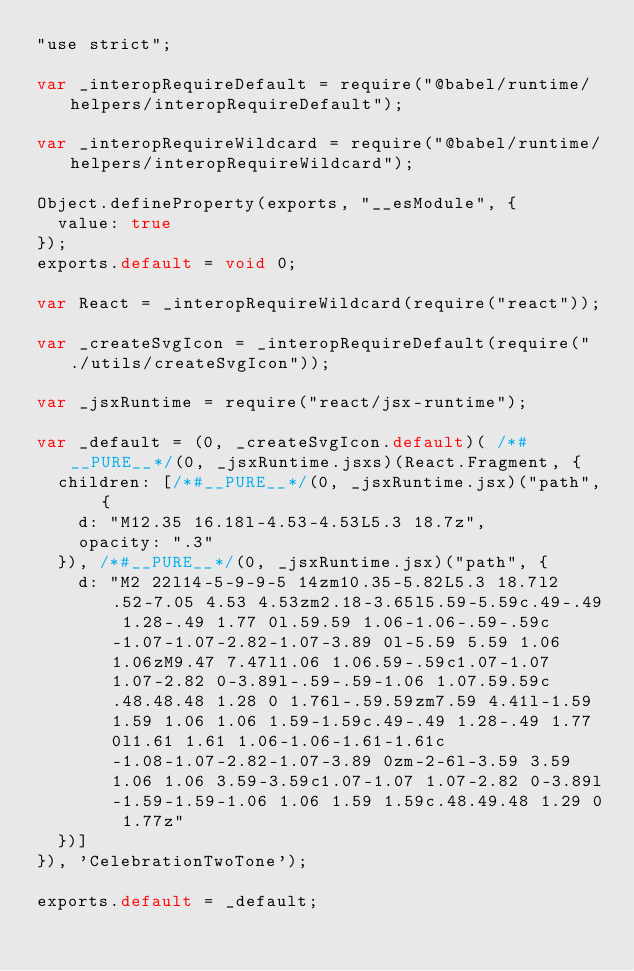Convert code to text. <code><loc_0><loc_0><loc_500><loc_500><_JavaScript_>"use strict";

var _interopRequireDefault = require("@babel/runtime/helpers/interopRequireDefault");

var _interopRequireWildcard = require("@babel/runtime/helpers/interopRequireWildcard");

Object.defineProperty(exports, "__esModule", {
  value: true
});
exports.default = void 0;

var React = _interopRequireWildcard(require("react"));

var _createSvgIcon = _interopRequireDefault(require("./utils/createSvgIcon"));

var _jsxRuntime = require("react/jsx-runtime");

var _default = (0, _createSvgIcon.default)( /*#__PURE__*/(0, _jsxRuntime.jsxs)(React.Fragment, {
  children: [/*#__PURE__*/(0, _jsxRuntime.jsx)("path", {
    d: "M12.35 16.18l-4.53-4.53L5.3 18.7z",
    opacity: ".3"
  }), /*#__PURE__*/(0, _jsxRuntime.jsx)("path", {
    d: "M2 22l14-5-9-9-5 14zm10.35-5.82L5.3 18.7l2.52-7.05 4.53 4.53zm2.18-3.65l5.59-5.59c.49-.49 1.28-.49 1.77 0l.59.59 1.06-1.06-.59-.59c-1.07-1.07-2.82-1.07-3.89 0l-5.59 5.59 1.06 1.06zM9.47 7.47l1.06 1.06.59-.59c1.07-1.07 1.07-2.82 0-3.89l-.59-.59-1.06 1.07.59.59c.48.48.48 1.28 0 1.76l-.59.59zm7.59 4.41l-1.59 1.59 1.06 1.06 1.59-1.59c.49-.49 1.28-.49 1.77 0l1.61 1.61 1.06-1.06-1.61-1.61c-1.08-1.07-2.82-1.07-3.89 0zm-2-6l-3.59 3.59 1.06 1.06 3.59-3.59c1.07-1.07 1.07-2.82 0-3.89l-1.59-1.59-1.06 1.06 1.59 1.59c.48.49.48 1.29 0 1.77z"
  })]
}), 'CelebrationTwoTone');

exports.default = _default;</code> 